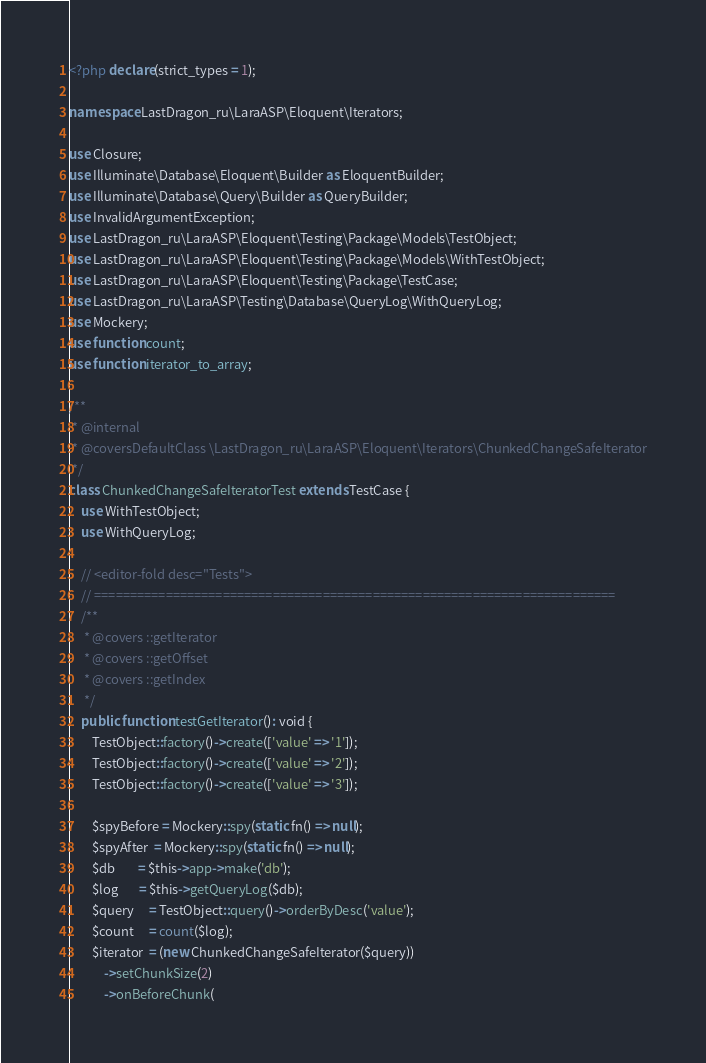<code> <loc_0><loc_0><loc_500><loc_500><_PHP_><?php declare(strict_types = 1);

namespace LastDragon_ru\LaraASP\Eloquent\Iterators;

use Closure;
use Illuminate\Database\Eloquent\Builder as EloquentBuilder;
use Illuminate\Database\Query\Builder as QueryBuilder;
use InvalidArgumentException;
use LastDragon_ru\LaraASP\Eloquent\Testing\Package\Models\TestObject;
use LastDragon_ru\LaraASP\Eloquent\Testing\Package\Models\WithTestObject;
use LastDragon_ru\LaraASP\Eloquent\Testing\Package\TestCase;
use LastDragon_ru\LaraASP\Testing\Database\QueryLog\WithQueryLog;
use Mockery;
use function count;
use function iterator_to_array;

/**
 * @internal
 * @coversDefaultClass \LastDragon_ru\LaraASP\Eloquent\Iterators\ChunkedChangeSafeIterator
 */
class ChunkedChangeSafeIteratorTest extends TestCase {
    use WithTestObject;
    use WithQueryLog;

    // <editor-fold desc="Tests">
    // =========================================================================
    /**
     * @covers ::getIterator
     * @covers ::getOffset
     * @covers ::getIndex
     */
    public function testGetIterator(): void {
        TestObject::factory()->create(['value' => '1']);
        TestObject::factory()->create(['value' => '2']);
        TestObject::factory()->create(['value' => '3']);

        $spyBefore = Mockery::spy(static fn() => null);
        $spyAfter  = Mockery::spy(static fn() => null);
        $db        = $this->app->make('db');
        $log       = $this->getQueryLog($db);
        $query     = TestObject::query()->orderByDesc('value');
        $count     = count($log);
        $iterator  = (new ChunkedChangeSafeIterator($query))
            ->setChunkSize(2)
            ->onBeforeChunk(</code> 